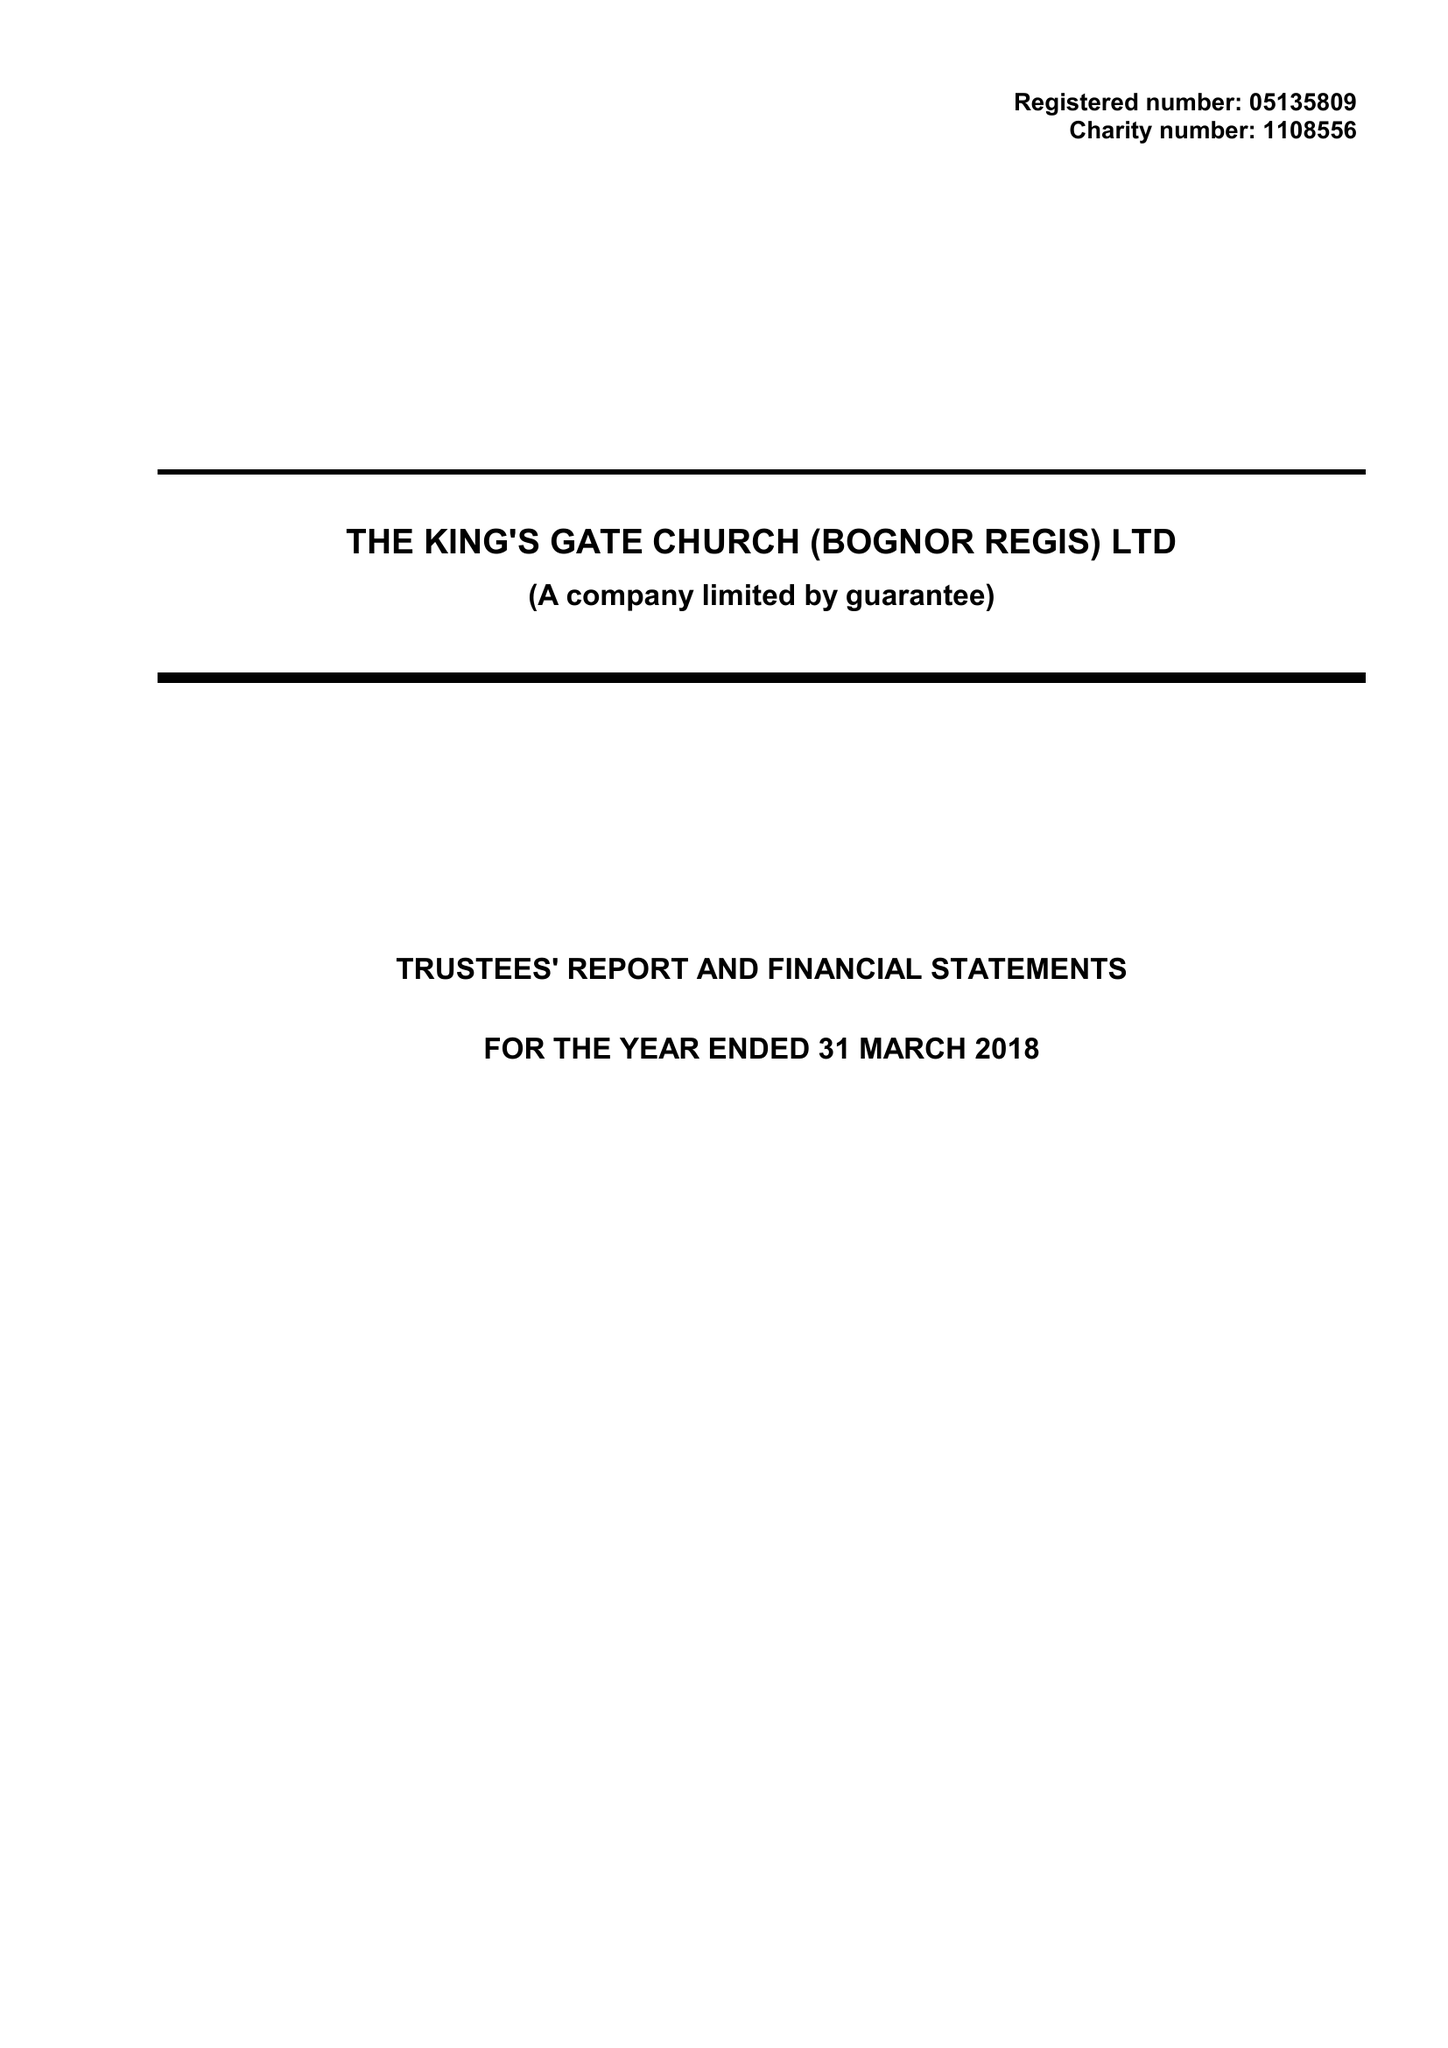What is the value for the spending_annually_in_british_pounds?
Answer the question using a single word or phrase. 47719.00 